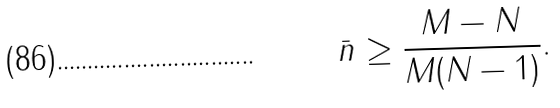Convert formula to latex. <formula><loc_0><loc_0><loc_500><loc_500>\bar { n } \geq \frac { M - N } { M ( N - 1 ) } .</formula> 